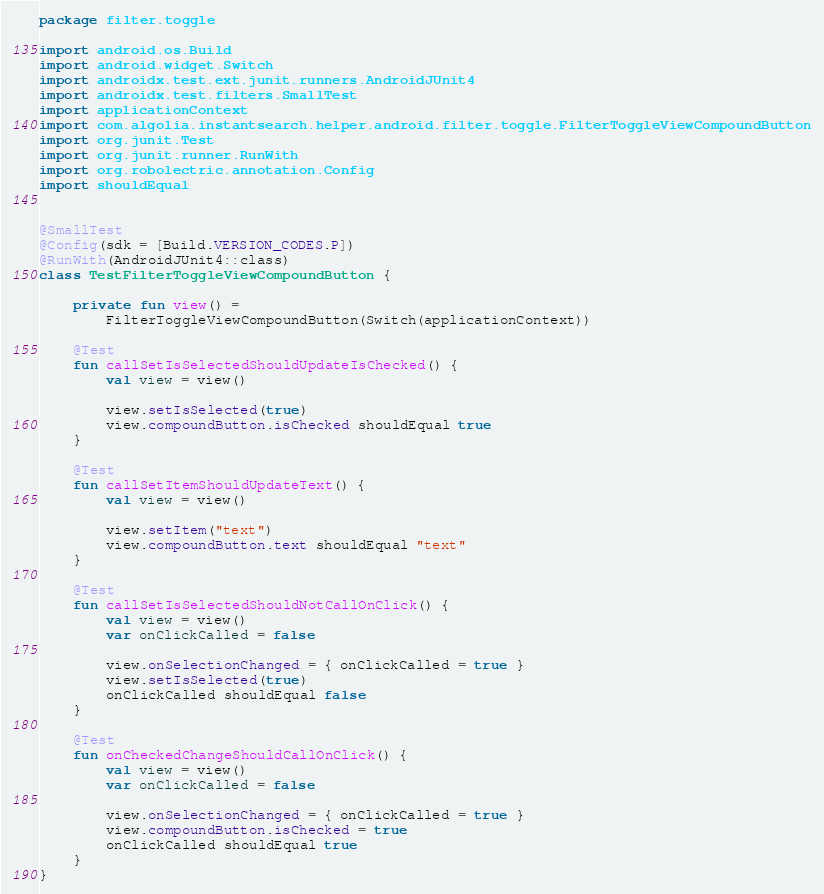<code> <loc_0><loc_0><loc_500><loc_500><_Kotlin_>package filter.toggle

import android.os.Build
import android.widget.Switch
import androidx.test.ext.junit.runners.AndroidJUnit4
import androidx.test.filters.SmallTest
import applicationContext
import com.algolia.instantsearch.helper.android.filter.toggle.FilterToggleViewCompoundButton
import org.junit.Test
import org.junit.runner.RunWith
import org.robolectric.annotation.Config
import shouldEqual


@SmallTest
@Config(sdk = [Build.VERSION_CODES.P])
@RunWith(AndroidJUnit4::class)
class TestFilterToggleViewCompoundButton {

    private fun view() =
        FilterToggleViewCompoundButton(Switch(applicationContext))

    @Test
    fun callSetIsSelectedShouldUpdateIsChecked() {
        val view = view()

        view.setIsSelected(true)
        view.compoundButton.isChecked shouldEqual true
    }

    @Test
    fun callSetItemShouldUpdateText() {
        val view = view()

        view.setItem("text")
        view.compoundButton.text shouldEqual "text"
    }

    @Test
    fun callSetIsSelectedShouldNotCallOnClick() {
        val view = view()
        var onClickCalled = false

        view.onSelectionChanged = { onClickCalled = true }
        view.setIsSelected(true)
        onClickCalled shouldEqual false
    }

    @Test
    fun onCheckedChangeShouldCallOnClick() {
        val view = view()
        var onClickCalled = false

        view.onSelectionChanged = { onClickCalled = true }
        view.compoundButton.isChecked = true
        onClickCalled shouldEqual true
    }
}</code> 